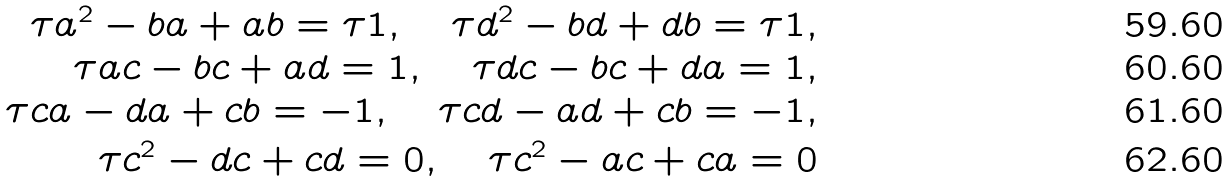<formula> <loc_0><loc_0><loc_500><loc_500>\tau a ^ { 2 } - b a + a b = \tau 1 , \quad \tau d ^ { 2 } - b d + d b = \tau 1 , \\ \tau a c - b c + a d = 1 , \quad \tau d c - b c + d a = 1 , \\ \tau c a - d a + c b = - 1 , \quad \tau c d - a d + c b = - 1 , \\ \tau c ^ { 2 } - d c + c d = 0 , \quad \tau c ^ { 2 } - a c + c a = 0</formula> 